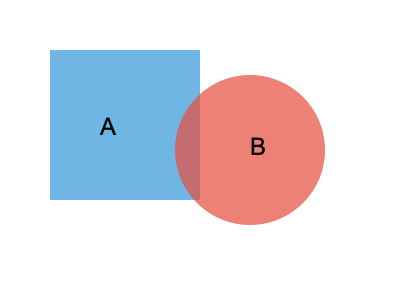In a trademark infringement case, Company A's logo is represented by the blue square, and Company B's logo is represented by the red circle. The overlapping area represents visual similarity. Calculate the percentage of similarity between the two logos, given that the area of the square is 22,500 sq units and the area of the circle is 17,671.46 sq units. How would you argue for or against trademark infringement based on this similarity percentage? To determine the similarity percentage and argue for or against trademark infringement, we need to follow these steps:

1. Calculate the area of overlap between the two shapes:
   a. Area of square = 22,500 sq units
   b. Side length of square = $\sqrt{22,500} = 150$ units
   c. Radius of circle = $\sqrt{17,671.46 / \pi} \approx 75$ units
   d. Area of overlap = Area of circular segment + Area of square segment

2. Calculate the area of the circular segment:
   a. Central angle $\theta = 2 \arccos(50/75) \approx 2.0944$ radians
   b. Area of sector = $\frac{1}{2} r^2 \theta \approx 5,890.49$ sq units
   c. Area of triangle = $\frac{1}{2} * 75 * 100 = 3,750$ sq units
   d. Area of circular segment = $5,890.49 - 3,750 = 2,140.49$ sq units

3. Calculate the area of the square segment:
   Area of square segment = $150 * 50 - 3,750 = 3,750$ sq units

4. Total area of overlap:
   $2,140.49 + 3,750 = 5,890.49$ sq units

5. Calculate the similarity percentage:
   Similarity percentage = $\frac{\text{Area of overlap}}{\text{Total area of both logos}} * 100\%$
   $= \frac{5,890.49}{22,500 + 17,671.46 - 5,890.49} * 100\% \approx 17.17\%$

6. Argument for trademark infringement:
   The 17.17% similarity could be considered substantial, especially if there are other factors like similar industry, market confusion, or intentional copying. This level of visual similarity may lead to consumer confusion and dilution of Company A's brand.

7. Argument against trademark infringement:
   A 17.17% similarity is relatively low, and the logos are still predominantly different. The basic shapes (square vs. circle) are distinct, and consumers are likely to differentiate between the two brands. Other factors, such as color schemes, text, and overall design elements, should be considered in addition to this basic shape similarity.
Answer: 17.17% similarity; argue based on industry context, consumer confusion, and additional design elements. 